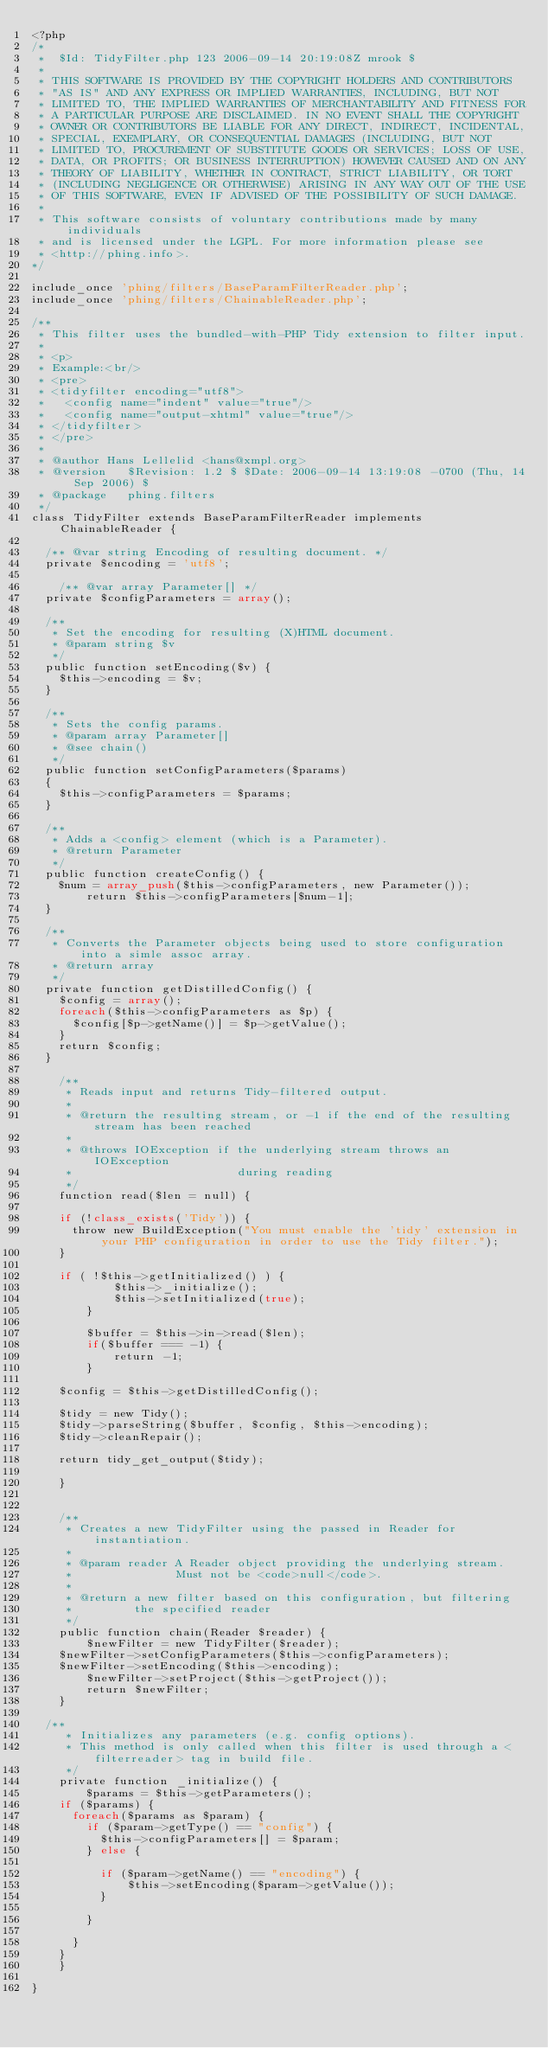Convert code to text. <code><loc_0><loc_0><loc_500><loc_500><_PHP_><?php
/*
 *  $Id: TidyFilter.php 123 2006-09-14 20:19:08Z mrook $  
 * 
 * THIS SOFTWARE IS PROVIDED BY THE COPYRIGHT HOLDERS AND CONTRIBUTORS
 * "AS IS" AND ANY EXPRESS OR IMPLIED WARRANTIES, INCLUDING, BUT NOT
 * LIMITED TO, THE IMPLIED WARRANTIES OF MERCHANTABILITY AND FITNESS FOR
 * A PARTICULAR PURPOSE ARE DISCLAIMED. IN NO EVENT SHALL THE COPYRIGHT
 * OWNER OR CONTRIBUTORS BE LIABLE FOR ANY DIRECT, INDIRECT, INCIDENTAL,
 * SPECIAL, EXEMPLARY, OR CONSEQUENTIAL DAMAGES (INCLUDING, BUT NOT
 * LIMITED TO, PROCUREMENT OF SUBSTITUTE GOODS OR SERVICES; LOSS OF USE,
 * DATA, OR PROFITS; OR BUSINESS INTERRUPTION) HOWEVER CAUSED AND ON ANY
 * THEORY OF LIABILITY, WHETHER IN CONTRACT, STRICT LIABILITY, OR TORT
 * (INCLUDING NEGLIGENCE OR OTHERWISE) ARISING IN ANY WAY OUT OF THE USE
 * OF THIS SOFTWARE, EVEN IF ADVISED OF THE POSSIBILITY OF SUCH DAMAGE.
 *
 * This software consists of voluntary contributions made by many individuals
 * and is licensed under the LGPL. For more information please see
 * <http://phing.info>.
*/

include_once 'phing/filters/BaseParamFilterReader.php';
include_once 'phing/filters/ChainableReader.php';

/**
 * This filter uses the bundled-with-PHP Tidy extension to filter input.
 * 
 * <p>
 * Example:<br/>
 * <pre>
 * <tidyfilter encoding="utf8">
 *   <config name="indent" value="true"/>
 *   <config name="output-xhtml" value="true"/>
 * </tidyfilter>
 * </pre>
 * 
 * @author Hans Lellelid <hans@xmpl.org>
 * @version   $Revision: 1.2 $ $Date: 2006-09-14 13:19:08 -0700 (Thu, 14 Sep 2006) $
 * @package   phing.filters
 */
class TidyFilter extends BaseParamFilterReader implements ChainableReader {
   	
	/** @var string Encoding of resulting document. */
	private $encoding = 'utf8';
   
    /** @var array Parameter[] */
	private $configParameters = array();
     
	/**
	 * Set the encoding for resulting (X)HTML document.
	 * @param string $v
	 */
	public function setEncoding($v) {
		$this->encoding = $v;
	}
	
	/**
	 * Sets the config params.
	 * @param array Parameter[]
	 * @see chain()
	 */
	public function setConfigParameters($params)
	{
		$this->configParameters = $params;
	}
	
	/**
	 * Adds a <config> element (which is a Parameter).
	 * @return Parameter
	 */
	public function createConfig() {
		$num = array_push($this->configParameters, new Parameter());
        return $this->configParameters[$num-1];
	}
	
	/**
	 * Converts the Parameter objects being used to store configuration into a simle assoc array.
	 * @return array
	 */
	private function getDistilledConfig() {
		$config = array();
		foreach($this->configParameters as $p) {
			$config[$p->getName()] = $p->getValue();
		}
		return $config;
	}
	
    /**
     * Reads input and returns Tidy-filtered output.
     * 
     * @return the resulting stream, or -1 if the end of the resulting stream has been reached
     * 
     * @throws IOException if the underlying stream throws an IOException
     *                        during reading     
     */
    function read($len = null) {
    	
		if (!class_exists('Tidy')) {
			throw new BuildException("You must enable the 'tidy' extension in your PHP configuration in order to use the Tidy filter.");
		}
		
		if ( !$this->getInitialized() ) {
            $this->_initialize();
            $this->setInitialized(true);
        }
		
        $buffer = $this->in->read($len);
        if($buffer === -1) {
            return -1;
        }
		
		$config = $this->getDistilledConfig();
		
		$tidy = new Tidy();
		$tidy->parseString($buffer, $config, $this->encoding);
		$tidy->cleanRepair();

		return tidy_get_output($tidy);
		
    }


    /**
     * Creates a new TidyFilter using the passed in Reader for instantiation.
     * 
     * @param reader A Reader object providing the underlying stream.
     *               Must not be <code>null</code>.
     * 
     * @return a new filter based on this configuration, but filtering
     *         the specified reader
     */
    public function chain(Reader $reader) {
        $newFilter = new TidyFilter($reader);
		$newFilter->setConfigParameters($this->configParameters);
		$newFilter->setEncoding($this->encoding);
        $newFilter->setProject($this->getProject());
        return $newFilter;
    }
	
	/**
     * Initializes any parameters (e.g. config options).
     * This method is only called when this filter is used through a <filterreader> tag in build file.
     */
    private function _initialize() {
        $params = $this->getParameters();
		if ($params) {
			foreach($params as $param) {
				if ($param->getType() == "config") {
					$this->configParameters[] = $param;
				} else {
					
					if ($param->getName() == "encoding") {
					    $this->setEncoding($param->getValue());
					}
					
				}
				
			}
		}
    }

}
</code> 